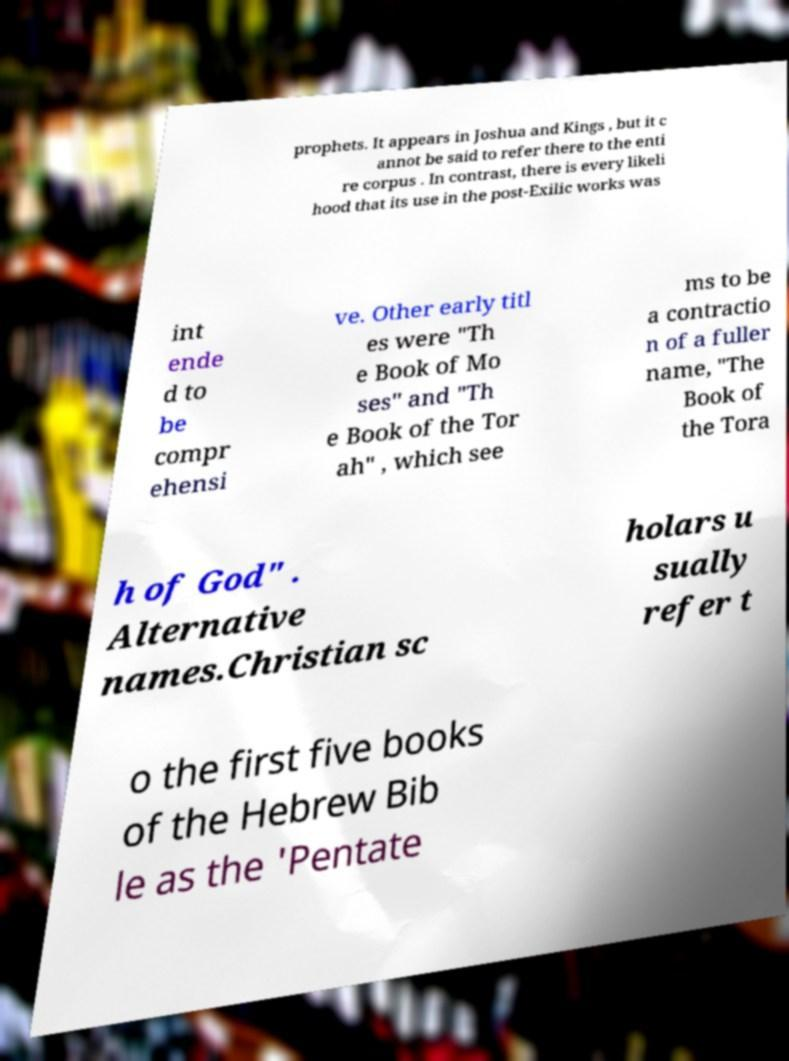Can you accurately transcribe the text from the provided image for me? prophets. It appears in Joshua and Kings , but it c annot be said to refer there to the enti re corpus . In contrast, there is every likeli hood that its use in the post-Exilic works was int ende d to be compr ehensi ve. Other early titl es were "Th e Book of Mo ses" and "Th e Book of the Tor ah" , which see ms to be a contractio n of a fuller name, "The Book of the Tora h of God" . Alternative names.Christian sc holars u sually refer t o the first five books of the Hebrew Bib le as the 'Pentate 